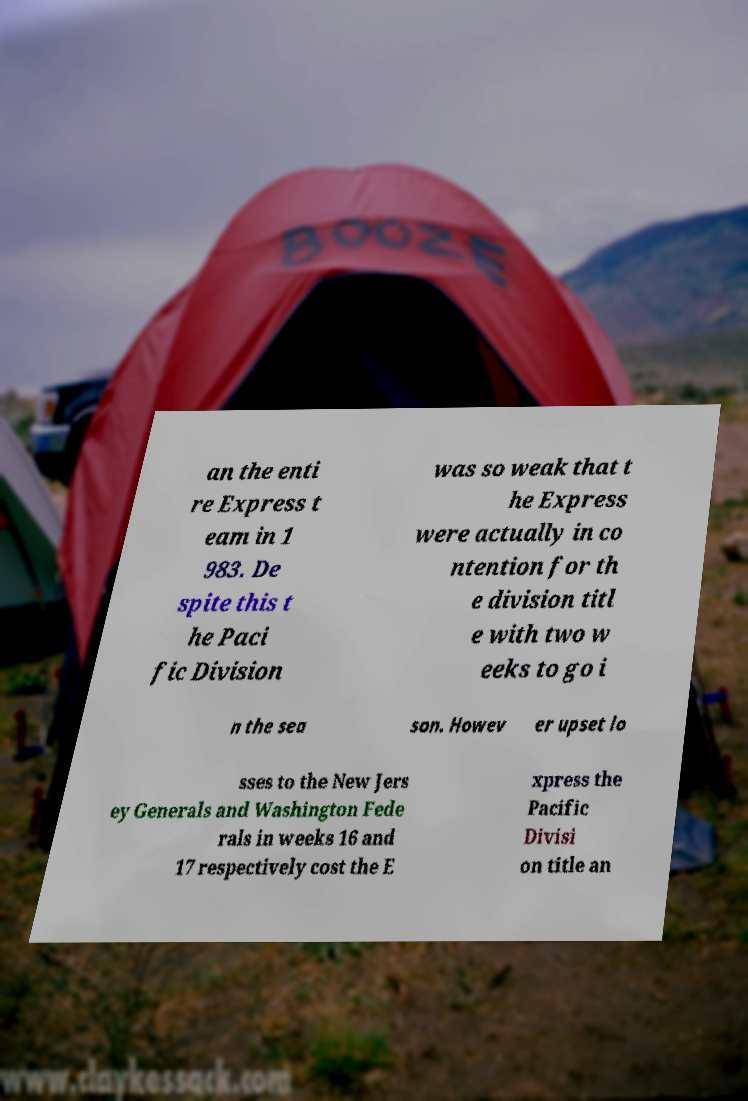There's text embedded in this image that I need extracted. Can you transcribe it verbatim? an the enti re Express t eam in 1 983. De spite this t he Paci fic Division was so weak that t he Express were actually in co ntention for th e division titl e with two w eeks to go i n the sea son. Howev er upset lo sses to the New Jers ey Generals and Washington Fede rals in weeks 16 and 17 respectively cost the E xpress the Pacific Divisi on title an 